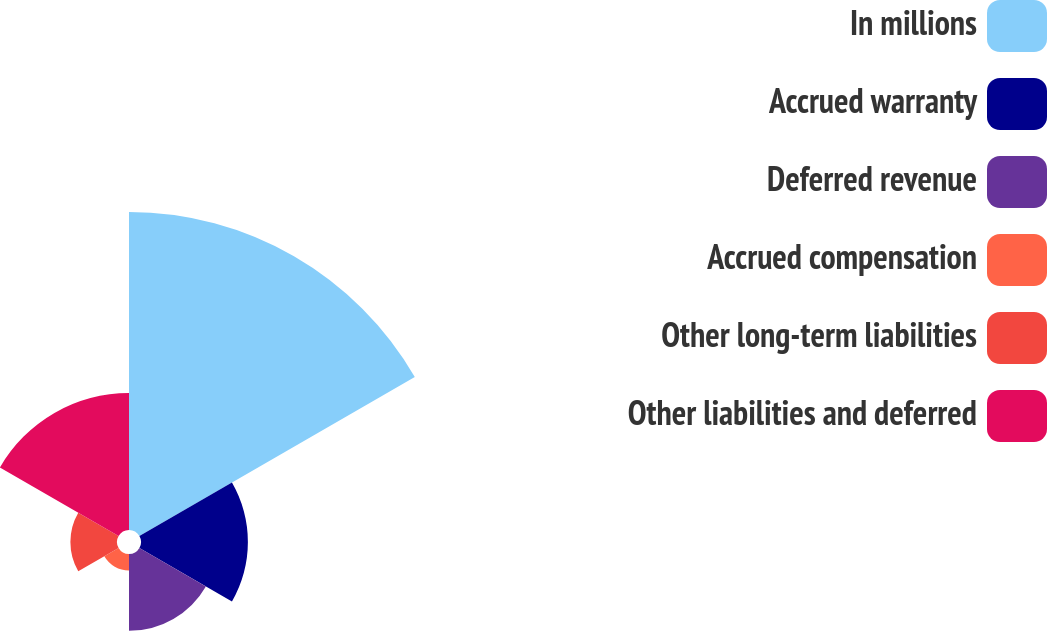<chart> <loc_0><loc_0><loc_500><loc_500><pie_chart><fcel>In millions<fcel>Accrued warranty<fcel>Deferred revenue<fcel>Accrued compensation<fcel>Other long-term liabilities<fcel>Other liabilities and deferred<nl><fcel>45.31%<fcel>15.23%<fcel>10.94%<fcel>2.35%<fcel>6.64%<fcel>19.53%<nl></chart> 